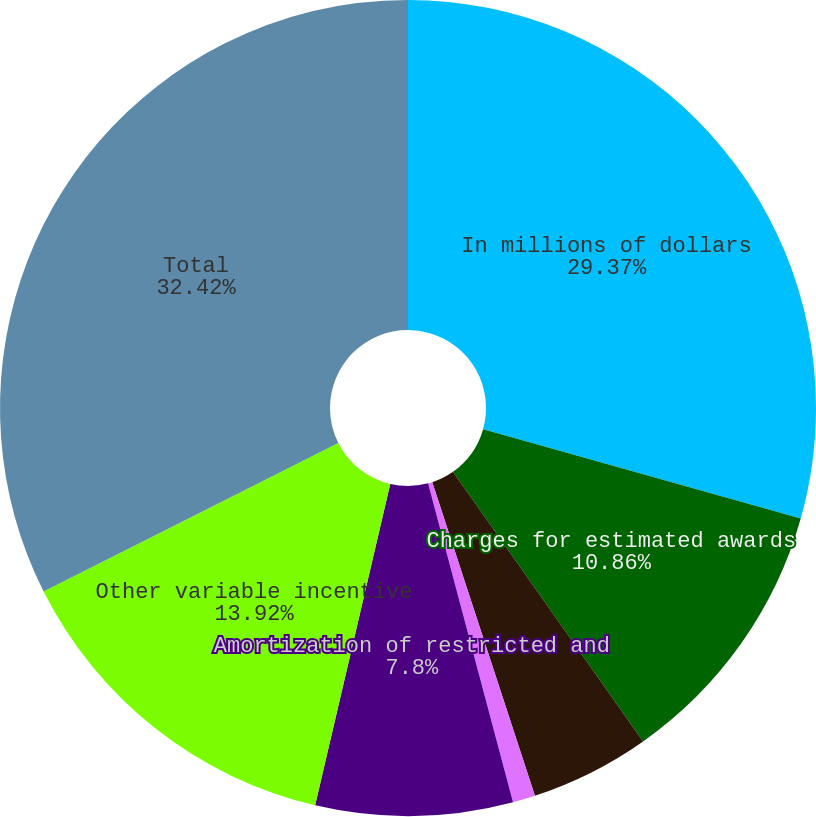<chart> <loc_0><loc_0><loc_500><loc_500><pie_chart><fcel>In millions of dollars<fcel>Charges for estimated awards<fcel>Amortization of deferred cash<fcel>Immediately vested stock award<fcel>Amortization of restricted and<fcel>Other variable incentive<fcel>Total<nl><fcel>29.37%<fcel>10.86%<fcel>4.74%<fcel>0.89%<fcel>7.8%<fcel>13.92%<fcel>32.43%<nl></chart> 